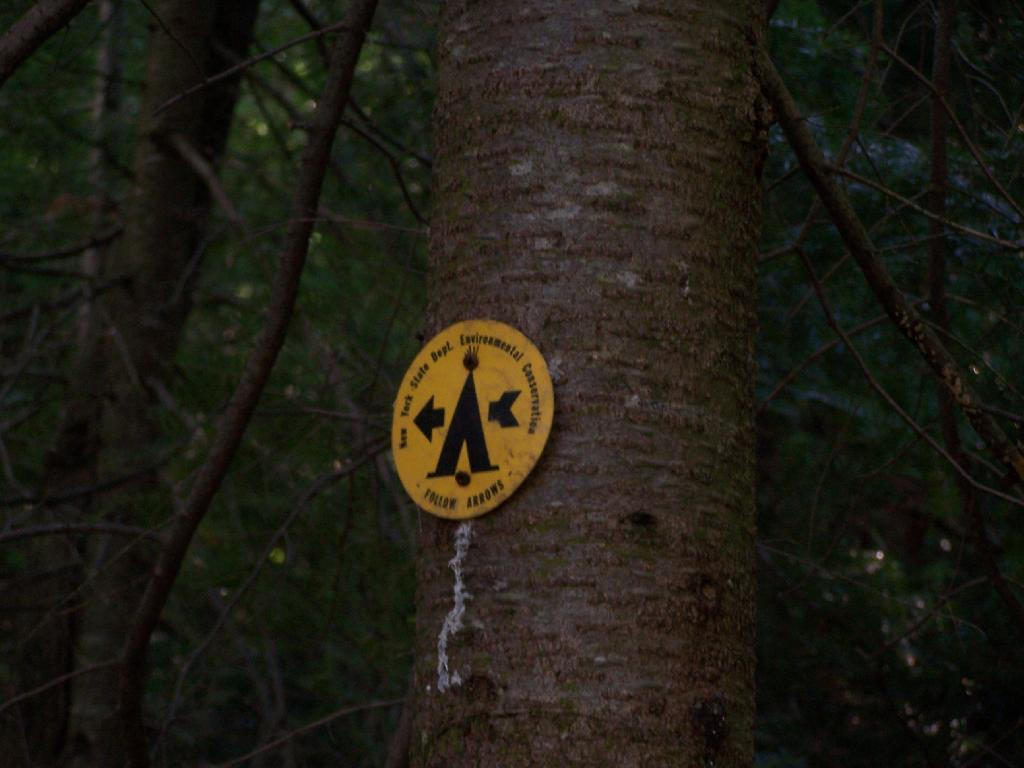What is the main subject of the image? The main subject of the image is a tree with a caution board. Can you describe the caution board? The caution board is attached to the tree, likely indicating a potential hazard or warning. What else can be seen in the image? In the background of the image, there are many trees visible. How many eggs are present on the tree in the image? There are no eggs present on the tree in the image; it has a caution board attached to it. What type of ear is visible on the tree in the image? There is no ear present on the tree in the image; it has a caution board attached to it. 